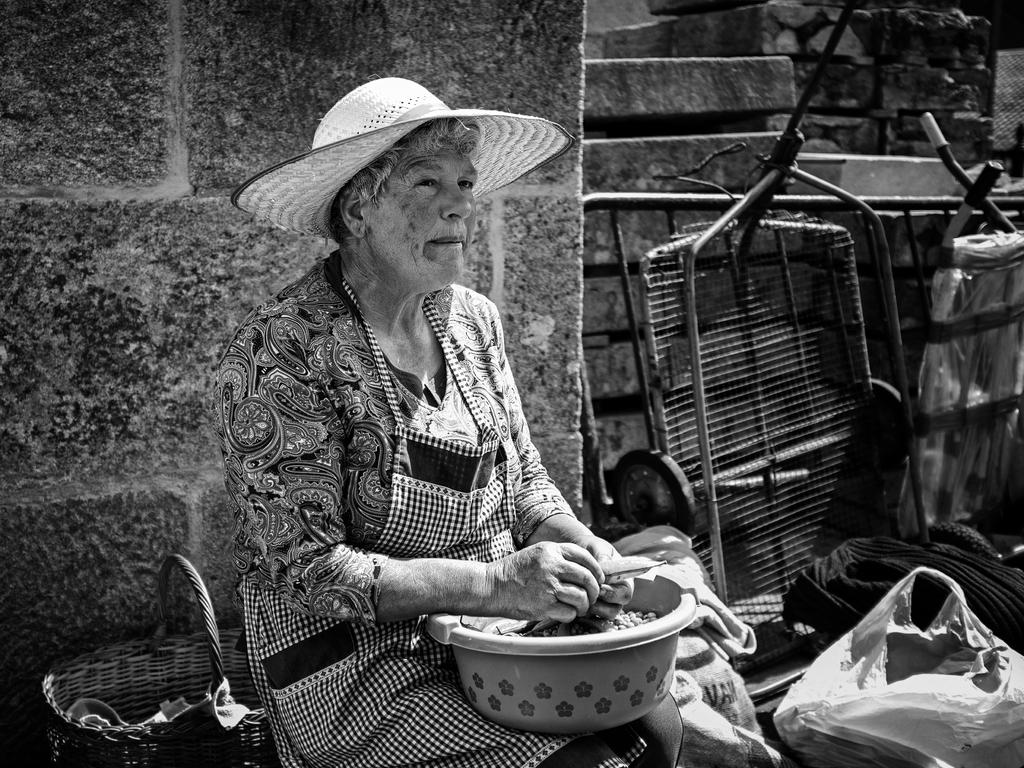Who is the main subject in the picture? There is a woman in the picture. Where is the woman located in the image? The woman is sitting near a wall. What is the woman wearing on her head? The woman is wearing a hat. What is the woman doing in the image? The woman is doing some work. What object is beside the woman? There is a cart beside the woman. What can be seen near the wall in the image? There are things placed near the wall. What type of fowl is the woman talking to in the image? There is no fowl present in the image, and the woman is not talking to anyone. 